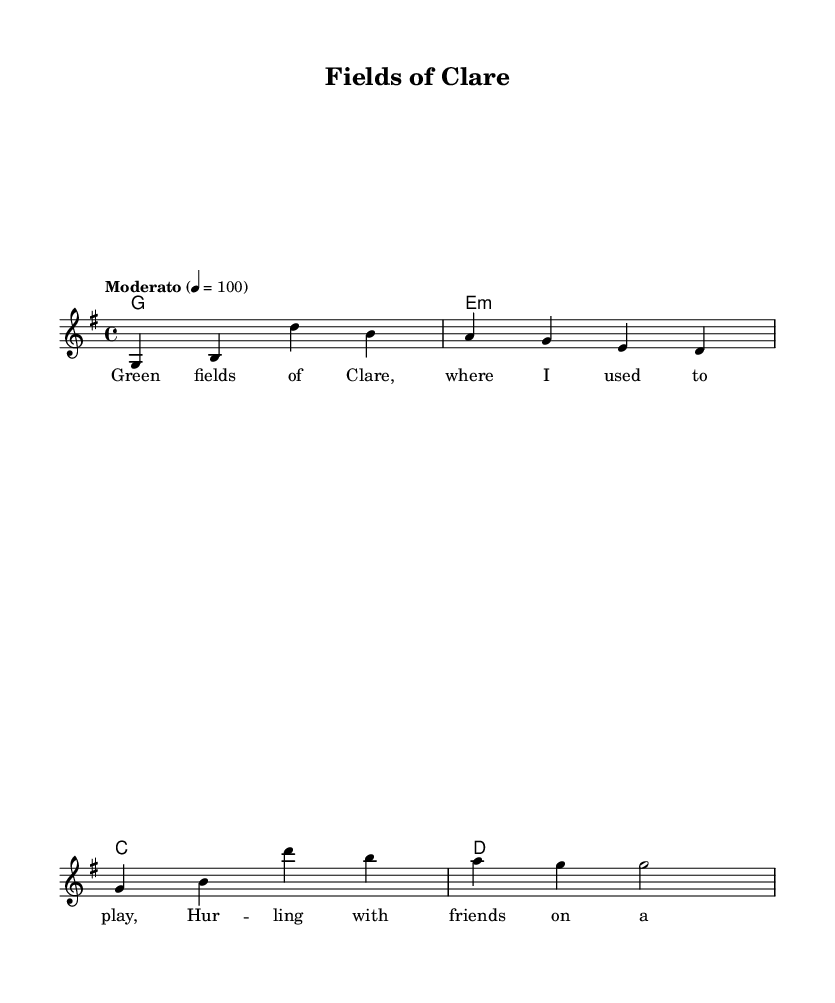What is the key signature of this music? The key signature is indicated at the beginning of the score, which shows one sharp, corresponding to the key of G major.
Answer: G major What is the time signature of the piece? The time signature is found at the beginning of the score, showing that each measure is divided into four beats. This is noted as 4/4.
Answer: 4/4 What is the tempo marking for this piece? The tempo marking appears at the start of the score, indicating "Moderato." This gives a speed of 100 beats per minute.
Answer: Moderato How many measures are in the melody? The melody section contains four measures, which can be counted visually in the score.
Answer: Four What is the first lyric of the song? The lyric is presented below the melody, with the first word being "Green" as it starts the verse.
Answer: Green What type of musical composition is this? The overall structure consists of lyrics, melody, and harmonies, which are characteristic of a folk or country song reflecting rural life themes.
Answer: Folk song How does the melody begin? The melody starts on the note G and is indicated by the first note in the melody line at the beginning of the score.
Answer: G 